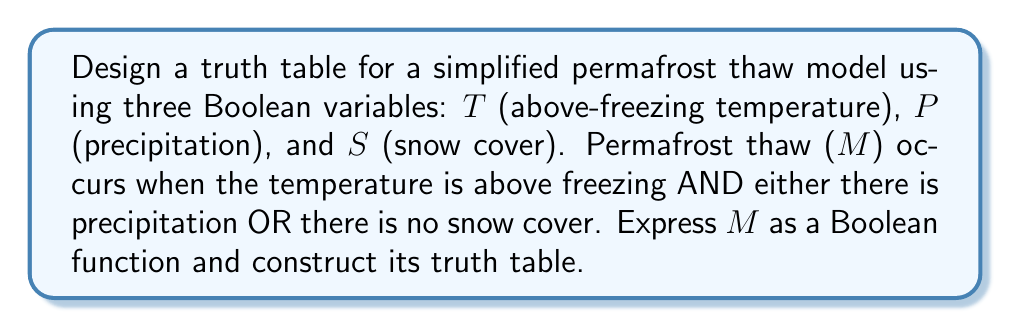Teach me how to tackle this problem. 1. First, let's express the permafrost thaw condition ($M$) as a Boolean function:

   $M = T \cdot (P + \overline{S})$

   Where $\cdot$ represents AND, $+$ represents OR, and $\overline{S}$ represents NOT $S$.

2. To construct the truth table, we need to consider all possible combinations of the input variables $T$, $P$, and $S$. With three variables, we have $2^3 = 8$ possible combinations.

3. Let's evaluate the function $M$ for each combination:

   $$\begin{array}{|c|c|c|c|c|c|c|}
   \hline
   T & P & S & \overline{S} & P + \overline{S} & M = T \cdot (P + \overline{S}) \\
   \hline
   0 & 0 & 0 & 1 & 1 & 0 \\
   0 & 0 & 1 & 0 & 0 & 0 \\
   0 & 1 & 0 & 1 & 1 & 0 \\
   0 & 1 & 1 & 0 & 1 & 0 \\
   1 & 0 & 0 & 1 & 1 & 1 \\
   1 & 0 & 1 & 0 & 0 & 0 \\
   1 & 1 & 0 & 1 & 1 & 1 \\
   1 & 1 & 1 & 0 & 1 & 1 \\
   \hline
   \end{array}$$

4. The resulting truth table shows the output $M$ for all possible combinations of inputs $T$, $P$, and $S$.
Answer: $M = T \cdot (P + \overline{S})$; Truth table:
$$\begin{array}{|c|c|c|c|}
\hline
T & P & S & M \\
\hline
0 & 0 & 0 & 0 \\
0 & 0 & 1 & 0 \\
0 & 1 & 0 & 0 \\
0 & 1 & 1 & 0 \\
1 & 0 & 0 & 1 \\
1 & 0 & 1 & 0 \\
1 & 1 & 0 & 1 \\
1 & 1 & 1 & 1 \\
\hline
\end{array}$$ 